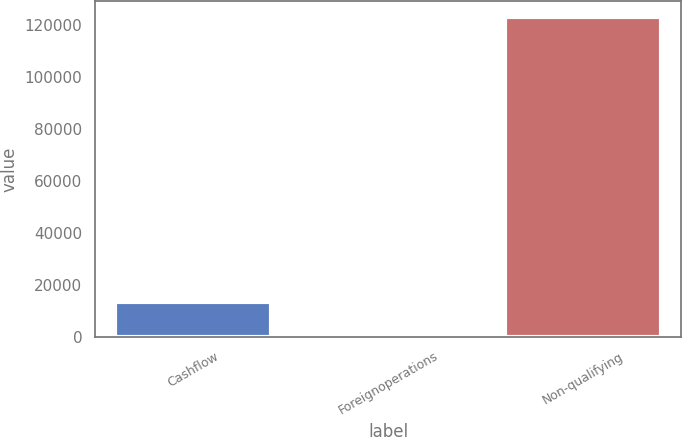<chart> <loc_0><loc_0><loc_500><loc_500><bar_chart><fcel>Cashflow<fcel>Foreignoperations<fcel>Non-qualifying<nl><fcel>13429.1<fcel>1232<fcel>123203<nl></chart> 